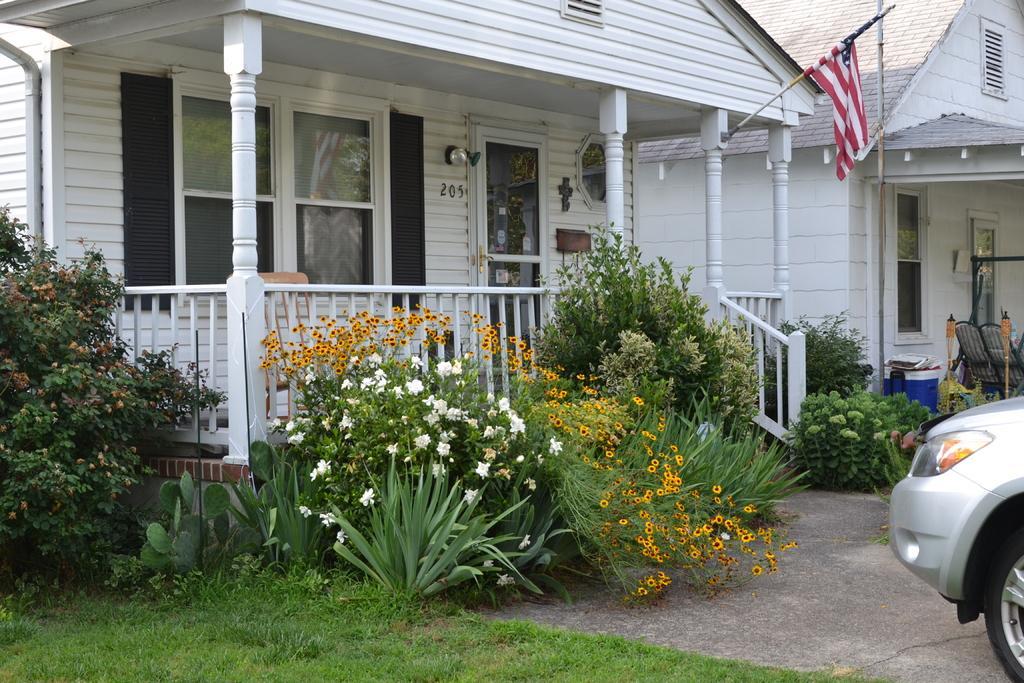Could you give a brief overview of what you see in this image? There is a building with windows, door, pillars and railings. In front of the building there are flowering plants. Also there is a flag with a pole. In the ground there is grass. On the right side there is a vehicle. Also there is another building with windows. In front of the building there are some items. 